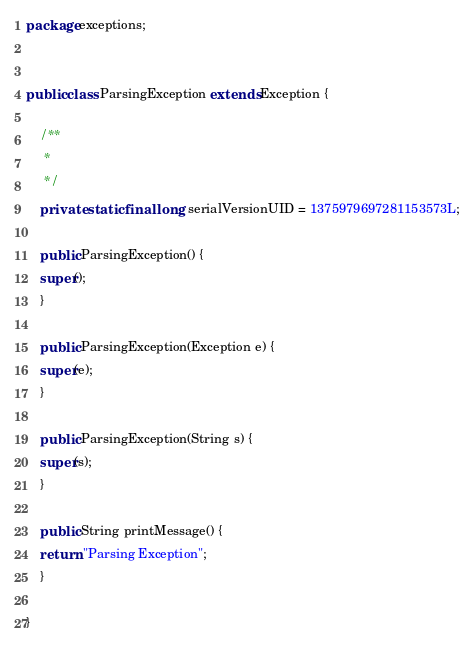<code> <loc_0><loc_0><loc_500><loc_500><_Java_>package exceptions;


public class ParsingException extends Exception {

    /**
     * 
     */
    private static final long serialVersionUID = 1375979697281153573L;

    public ParsingException() {
	super();
    }

    public ParsingException(Exception e) {
	super(e);
    }

    public ParsingException(String s) {
	super(s);
    }

    public String printMessage() {
	return "Parsing Exception";
    }

}
</code> 